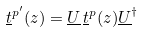<formula> <loc_0><loc_0><loc_500><loc_500>\underline { t } ^ { p ^ { \prime } } ( z ) = \underline { U } \, \underline { t } ^ { p } ( z ) \underline { U } ^ { \dagger }</formula> 